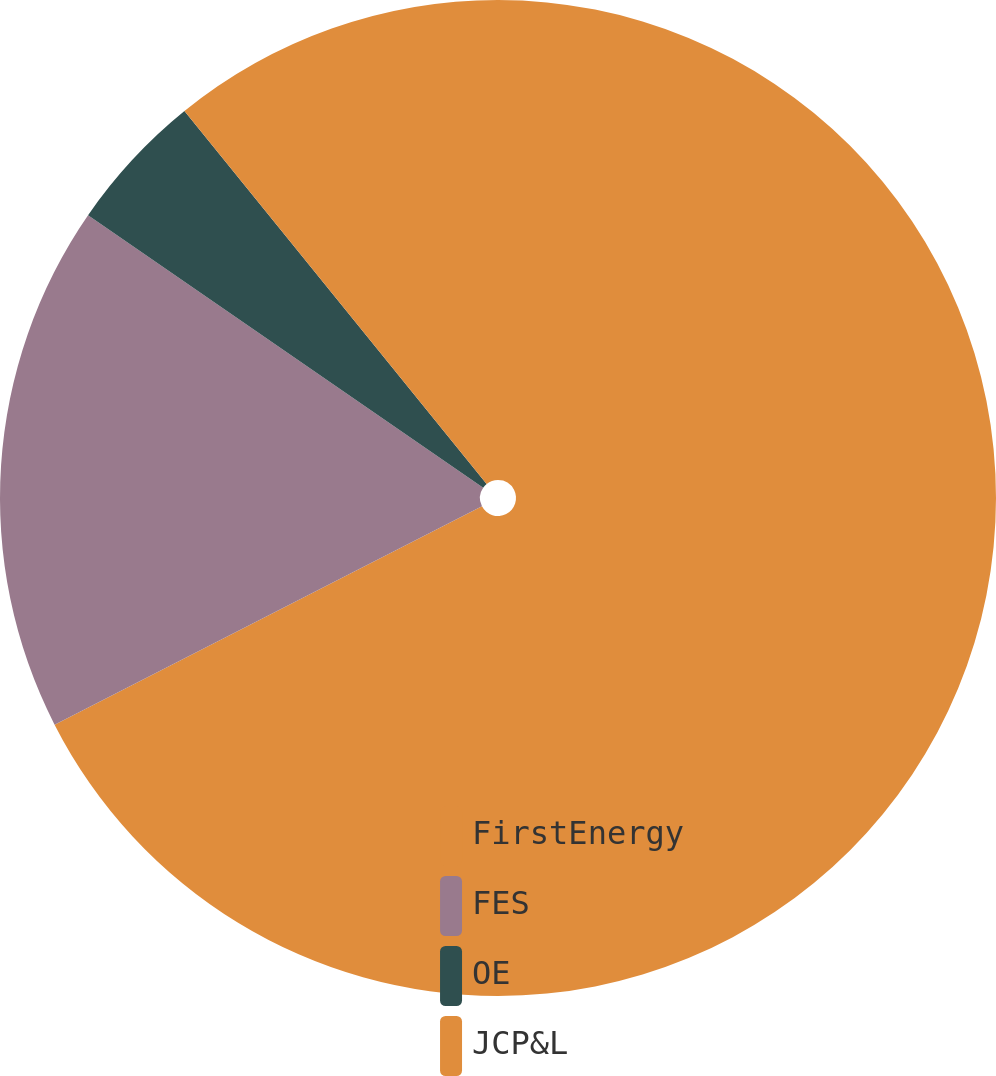Convert chart to OTSL. <chart><loc_0><loc_0><loc_500><loc_500><pie_chart><fcel>FirstEnergy<fcel>FES<fcel>OE<fcel>JCP&L<nl><fcel>67.48%<fcel>17.13%<fcel>4.55%<fcel>10.84%<nl></chart> 